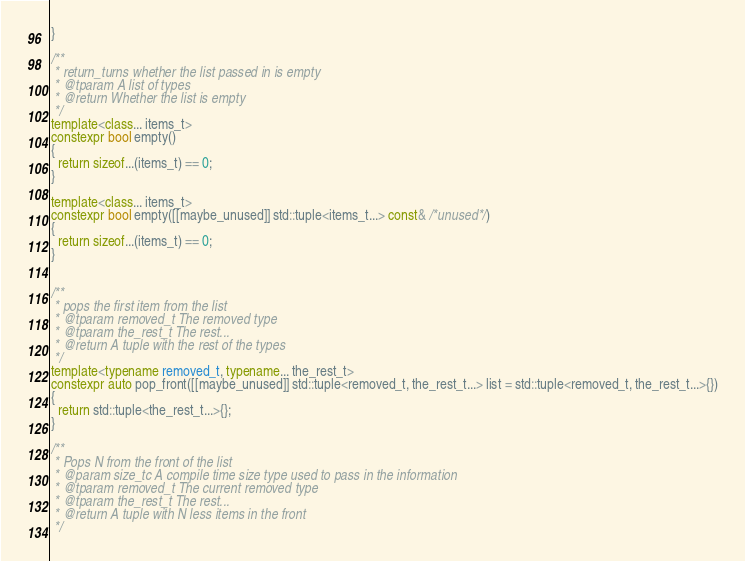Convert code to text. <code><loc_0><loc_0><loc_500><loc_500><_C++_>}

/**
 * return_turns whether the list passed in is empty
 * @tparam A list of types
 * @return Whether the list is empty
 */
template<class... items_t>
constexpr bool empty()
{
  return sizeof...(items_t) == 0;
}

template<class... items_t>
constexpr bool empty([[maybe_unused]] std::tuple<items_t...> const& /*unused*/)
{
  return sizeof...(items_t) == 0;
}


/**
 * pops the first item from the list
 * @tparam removed_t The removed type
 * @tparam the_rest_t The rest...
 * @return A tuple with the rest of the types
 */
template<typename removed_t, typename... the_rest_t>
constexpr auto pop_front([[maybe_unused]] std::tuple<removed_t, the_rest_t...> list = std::tuple<removed_t, the_rest_t...>{})
{
  return std::tuple<the_rest_t...>{};
}

/**
 * Pops N from the front of the list
 * @param size_tc A compile time size type used to pass in the information
 * @tparam removed_t The current removed type
 * @tparam the_rest_t The rest...
 * @return A tuple with N less items in the front
 */</code> 